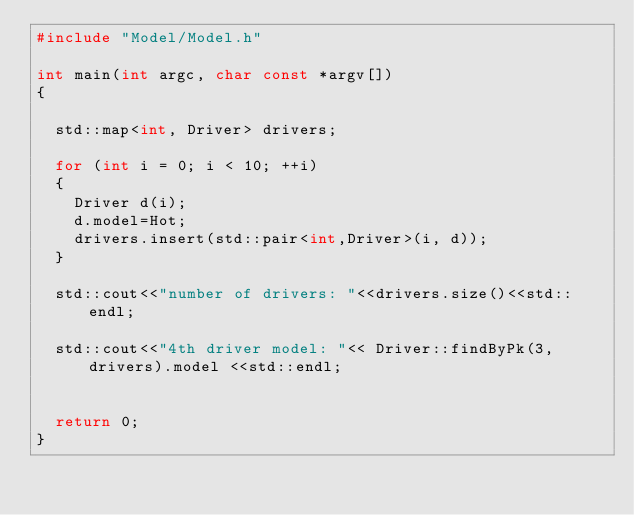<code> <loc_0><loc_0><loc_500><loc_500><_C++_>#include "Model/Model.h"

int main(int argc, char const *argv[])
{
	
	std::map<int, Driver> drivers;

	for (int i = 0; i < 10; ++i)
	{
		Driver d(i);
		d.model=Hot;
		drivers.insert(std::pair<int,Driver>(i, d));
	}

	std::cout<<"number of drivers: "<<drivers.size()<<std::endl;

	std::cout<<"4th driver model: "<< Driver::findByPk(3,drivers).model <<std::endl;
	

	return 0;
}</code> 